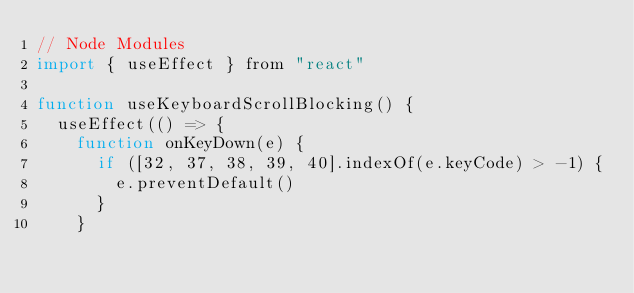Convert code to text. <code><loc_0><loc_0><loc_500><loc_500><_JavaScript_>// Node Modules
import { useEffect } from "react"

function useKeyboardScrollBlocking() {
  useEffect(() => {
    function onKeyDown(e) {
      if ([32, 37, 38, 39, 40].indexOf(e.keyCode) > -1) {
        e.preventDefault()
      }
    }
</code> 